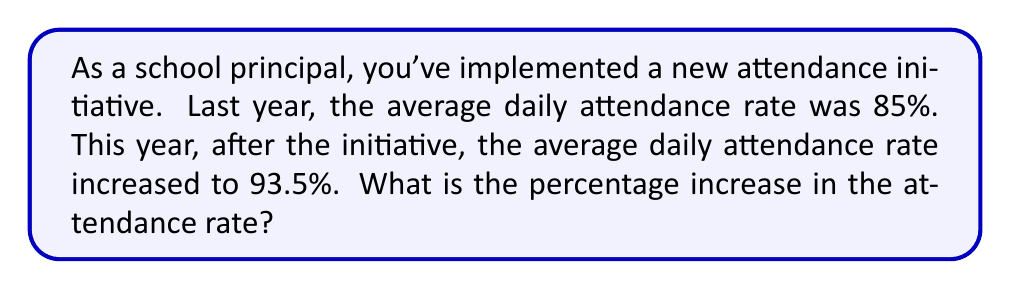What is the answer to this math problem? To calculate the percentage increase in the attendance rate, we need to follow these steps:

1. Calculate the difference between the new and old attendance rates:
   $93.5\% - 85\% = 8.5\%$

2. Divide this difference by the original attendance rate:
   $$\frac{8.5\%}{85\%} = \frac{8.5}{85} = 0.1$$

3. Multiply the result by 100 to express it as a percentage:
   $$0.1 \times 100 = 10\%$$

The formula for percentage increase can be expressed as:

$$\text{Percentage Increase} = \frac{\text{New Value} - \text{Original Value}}{\text{Original Value}} \times 100\%$$

Plugging in our values:

$$\text{Percentage Increase} = \frac{93.5\% - 85\%}{85\%} \times 100\% = \frac{8.5\%}{85\%} \times 100\% = 10\%$$

This means the attendance rate increased by 10% compared to the original rate.
Answer: The percentage increase in the attendance rate is 10%. 